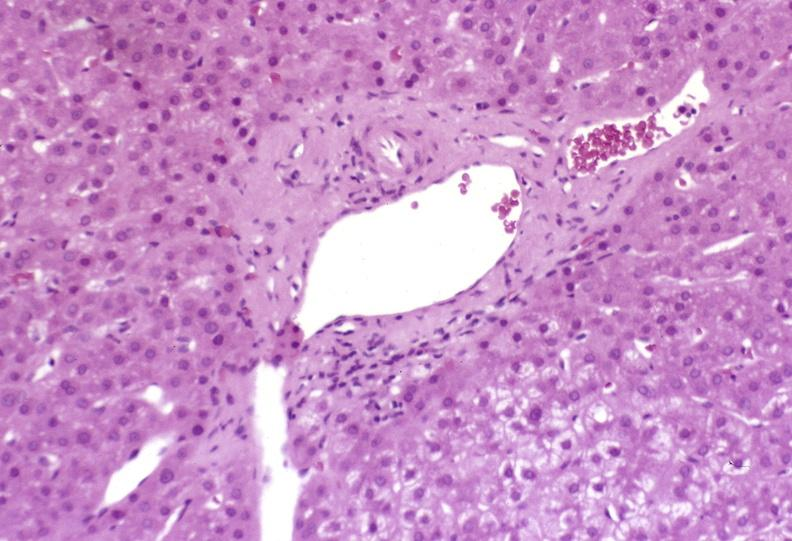s hepatobiliary present?
Answer the question using a single word or phrase. Yes 